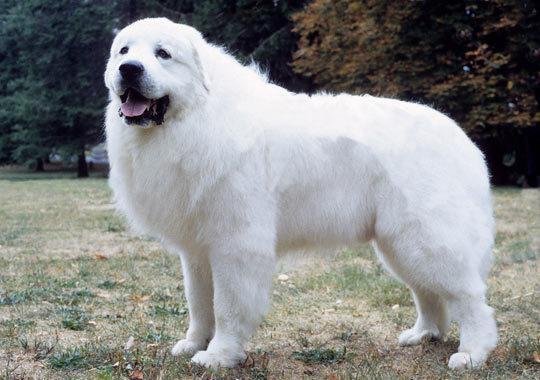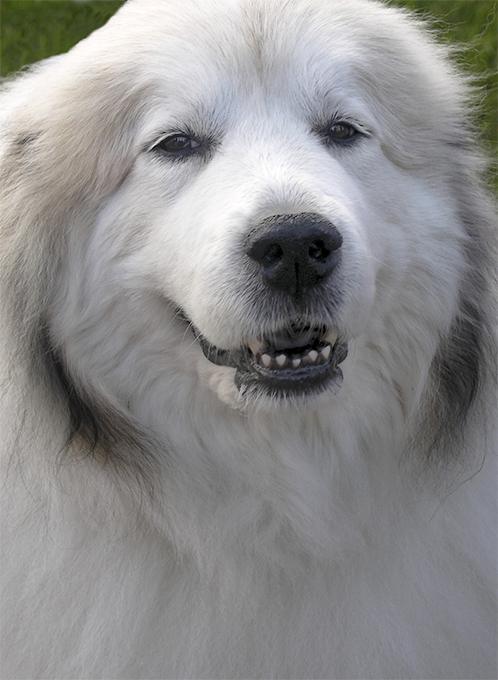The first image is the image on the left, the second image is the image on the right. For the images displayed, is the sentence "The dog is interacting with a human in one picture." factually correct? Answer yes or no. No. 